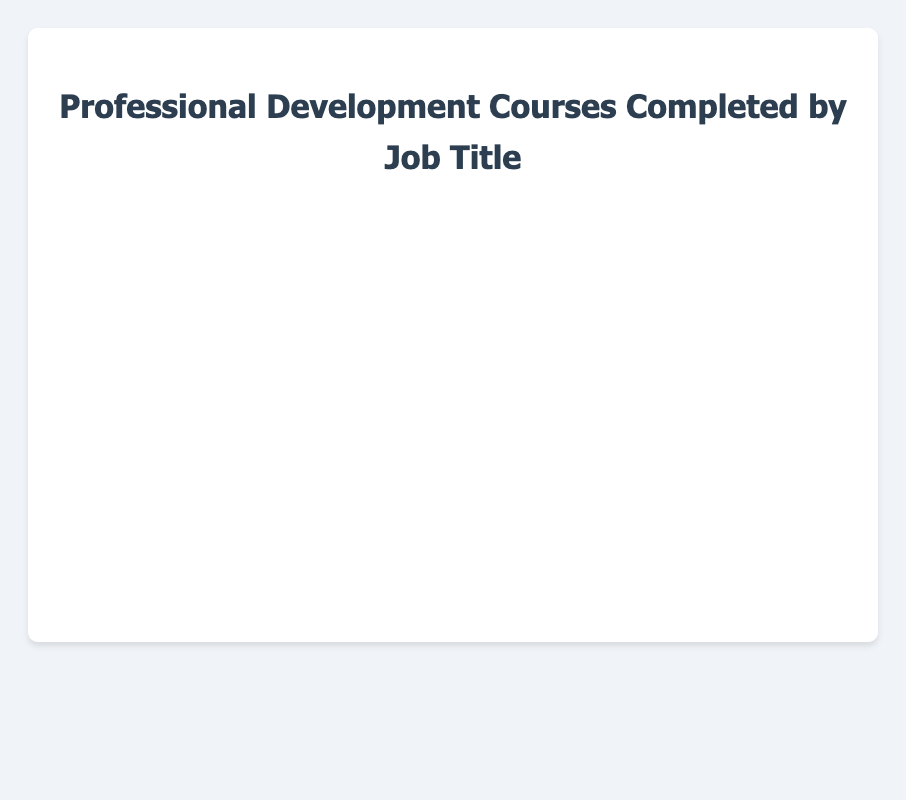What is the average number of professional development courses completed by Software Engineers? The chart shows the average number of courses completed for each job title. Find the bar labeled "Software Engineer" and read the value.
Answer: 12.5 Which job title has the highest average number of courses completed? Compare the values of all bars. The highest bar corresponds to the Product Manager job title.
Answer: Product Manager What is the total number of courses completed on average by Data Analysts and Marketing Specialists combined? Find the average courses completed for Data Analysts (7) and Marketing Specialists (5.5). Add these values together: 7 + 5.5 = 12.5
Answer: 12.5 Which job title has a lower average number of courses completed: Human Resources Manager or Customer Support Representative? Find the values for Human Resources Manager (6) and Customer Support Representative (8). Human Resources Manager has a lower average.
Answer: Human Resources Manager What is the difference in the average number of courses completed between Product Managers and Marketing Specialists? Find the averages for Product Managers (14.5) and Marketing Specialists (5.5). Calculate the difference: 14.5 - 5.5 = 9
Answer: 9 Which color represents the average number of courses completed by Graphic Designers? Find the bar labeled "Graphic Designer" and observe its color, which is blue.
Answer: Blue What is the second highest average number of courses completed by job title? After identifying Product Manager as the highest (14.5), check the remaining bars. Software Engineer comes next with 12.5.
Answer: Software Engineer Are there more job titles with an average number of courses completed above or below 10? Count the bars with values above (3) and below (5) 10. There are more job titles below 10.
Answer: Below 10 Which job titles have an average number of courses completed greater than 10? Identify the bars with values greater than 10: Software Engineer, Product Manager, and Graphic Designer.
Answer: Software Engineer, Product Manager, Graphic Designer 